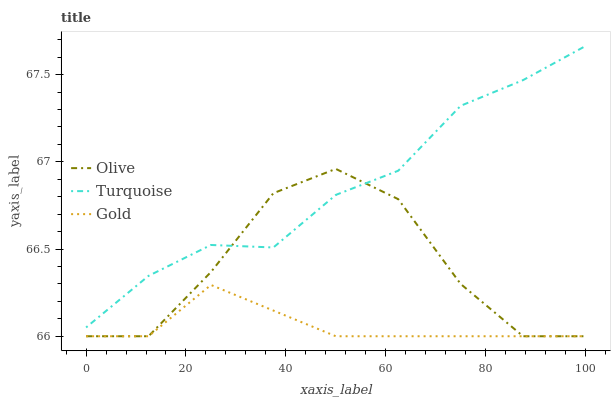Does Turquoise have the minimum area under the curve?
Answer yes or no. No. Does Gold have the maximum area under the curve?
Answer yes or no. No. Is Turquoise the smoothest?
Answer yes or no. No. Is Turquoise the roughest?
Answer yes or no. No. Does Turquoise have the lowest value?
Answer yes or no. No. Does Gold have the highest value?
Answer yes or no. No. Is Gold less than Turquoise?
Answer yes or no. Yes. Is Turquoise greater than Gold?
Answer yes or no. Yes. Does Gold intersect Turquoise?
Answer yes or no. No. 